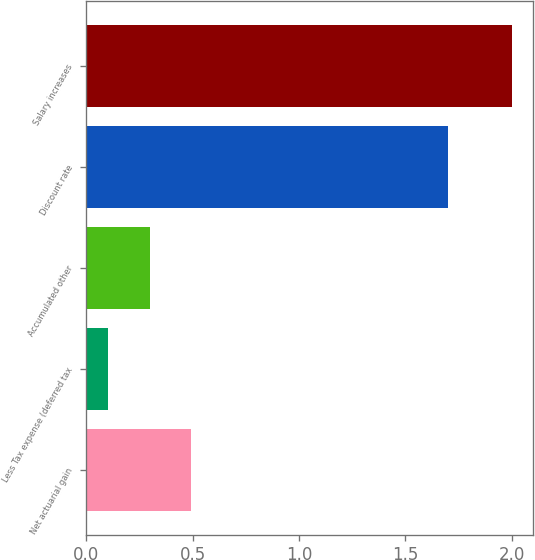Convert chart to OTSL. <chart><loc_0><loc_0><loc_500><loc_500><bar_chart><fcel>Net actuarial gain<fcel>Less Tax expense (deferred tax<fcel>Accumulated other<fcel>Discount rate<fcel>Salary increases<nl><fcel>0.49<fcel>0.1<fcel>0.3<fcel>1.7<fcel>2<nl></chart> 